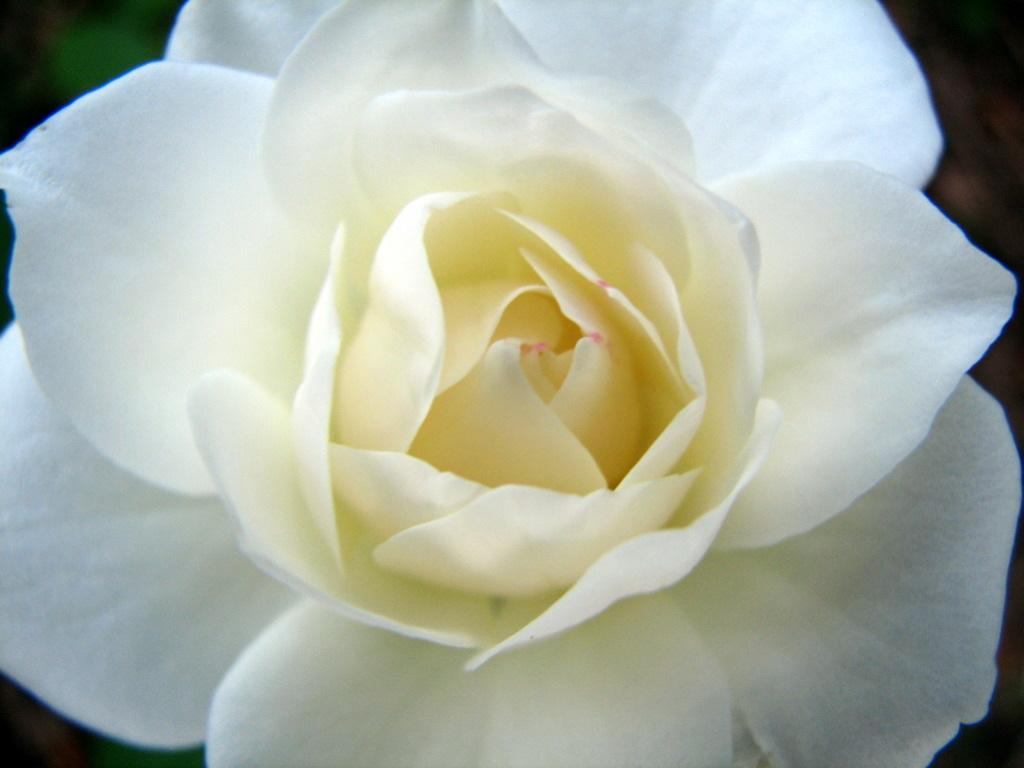What type of flower is in the image? There is a white color rose flower in the image. Can you describe the background of the image? The background of the image is blurred. How many bags of lettuce can be seen in the image? There are no bags of lettuce present in the image. What type of spiders can be seen crawling on the rose flower in the image? There are no spiders visible in the image, and the image only features a white color rose flower. 